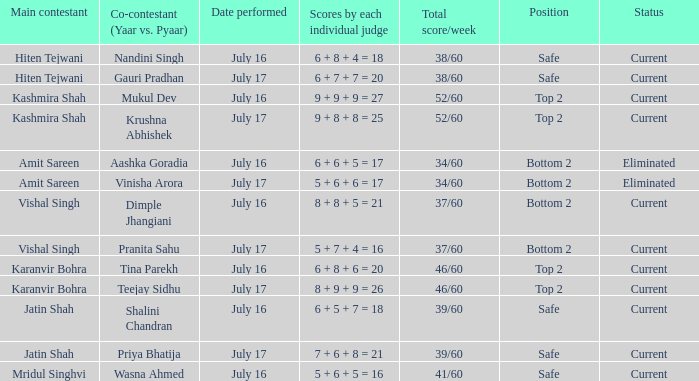What standing did the team with the cumulative score of 41/60 obtain? Safe. 